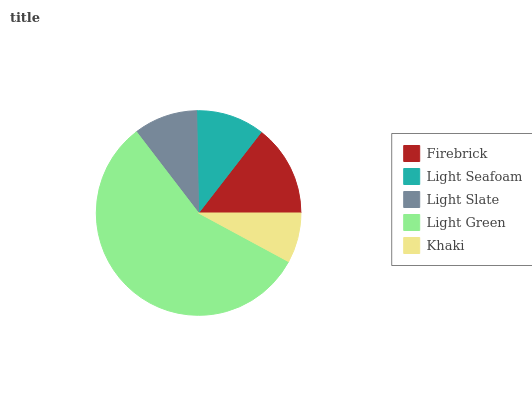Is Khaki the minimum?
Answer yes or no. Yes. Is Light Green the maximum?
Answer yes or no. Yes. Is Light Seafoam the minimum?
Answer yes or no. No. Is Light Seafoam the maximum?
Answer yes or no. No. Is Firebrick greater than Light Seafoam?
Answer yes or no. Yes. Is Light Seafoam less than Firebrick?
Answer yes or no. Yes. Is Light Seafoam greater than Firebrick?
Answer yes or no. No. Is Firebrick less than Light Seafoam?
Answer yes or no. No. Is Light Seafoam the high median?
Answer yes or no. Yes. Is Light Seafoam the low median?
Answer yes or no. Yes. Is Light Slate the high median?
Answer yes or no. No. Is Firebrick the low median?
Answer yes or no. No. 